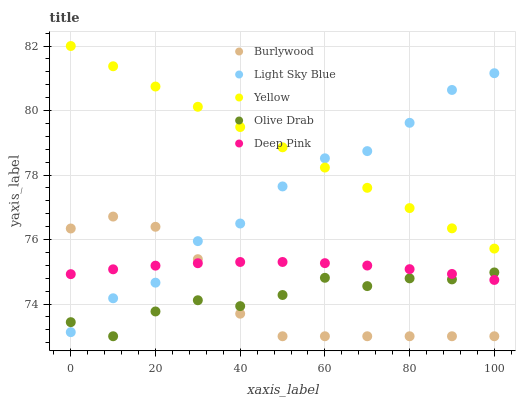Does Burlywood have the minimum area under the curve?
Answer yes or no. Yes. Does Yellow have the maximum area under the curve?
Answer yes or no. Yes. Does Light Sky Blue have the minimum area under the curve?
Answer yes or no. No. Does Light Sky Blue have the maximum area under the curve?
Answer yes or no. No. Is Yellow the smoothest?
Answer yes or no. Yes. Is Light Sky Blue the roughest?
Answer yes or no. Yes. Is Olive Drab the smoothest?
Answer yes or no. No. Is Olive Drab the roughest?
Answer yes or no. No. Does Burlywood have the lowest value?
Answer yes or no. Yes. Does Light Sky Blue have the lowest value?
Answer yes or no. No. Does Yellow have the highest value?
Answer yes or no. Yes. Does Light Sky Blue have the highest value?
Answer yes or no. No. Is Deep Pink less than Yellow?
Answer yes or no. Yes. Is Yellow greater than Olive Drab?
Answer yes or no. Yes. Does Burlywood intersect Deep Pink?
Answer yes or no. Yes. Is Burlywood less than Deep Pink?
Answer yes or no. No. Is Burlywood greater than Deep Pink?
Answer yes or no. No. Does Deep Pink intersect Yellow?
Answer yes or no. No. 